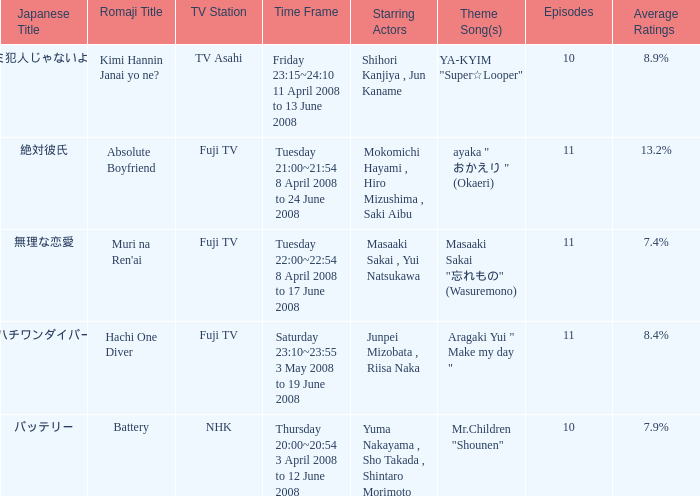How many titles had an average rating of 8.9%? 1.0. 